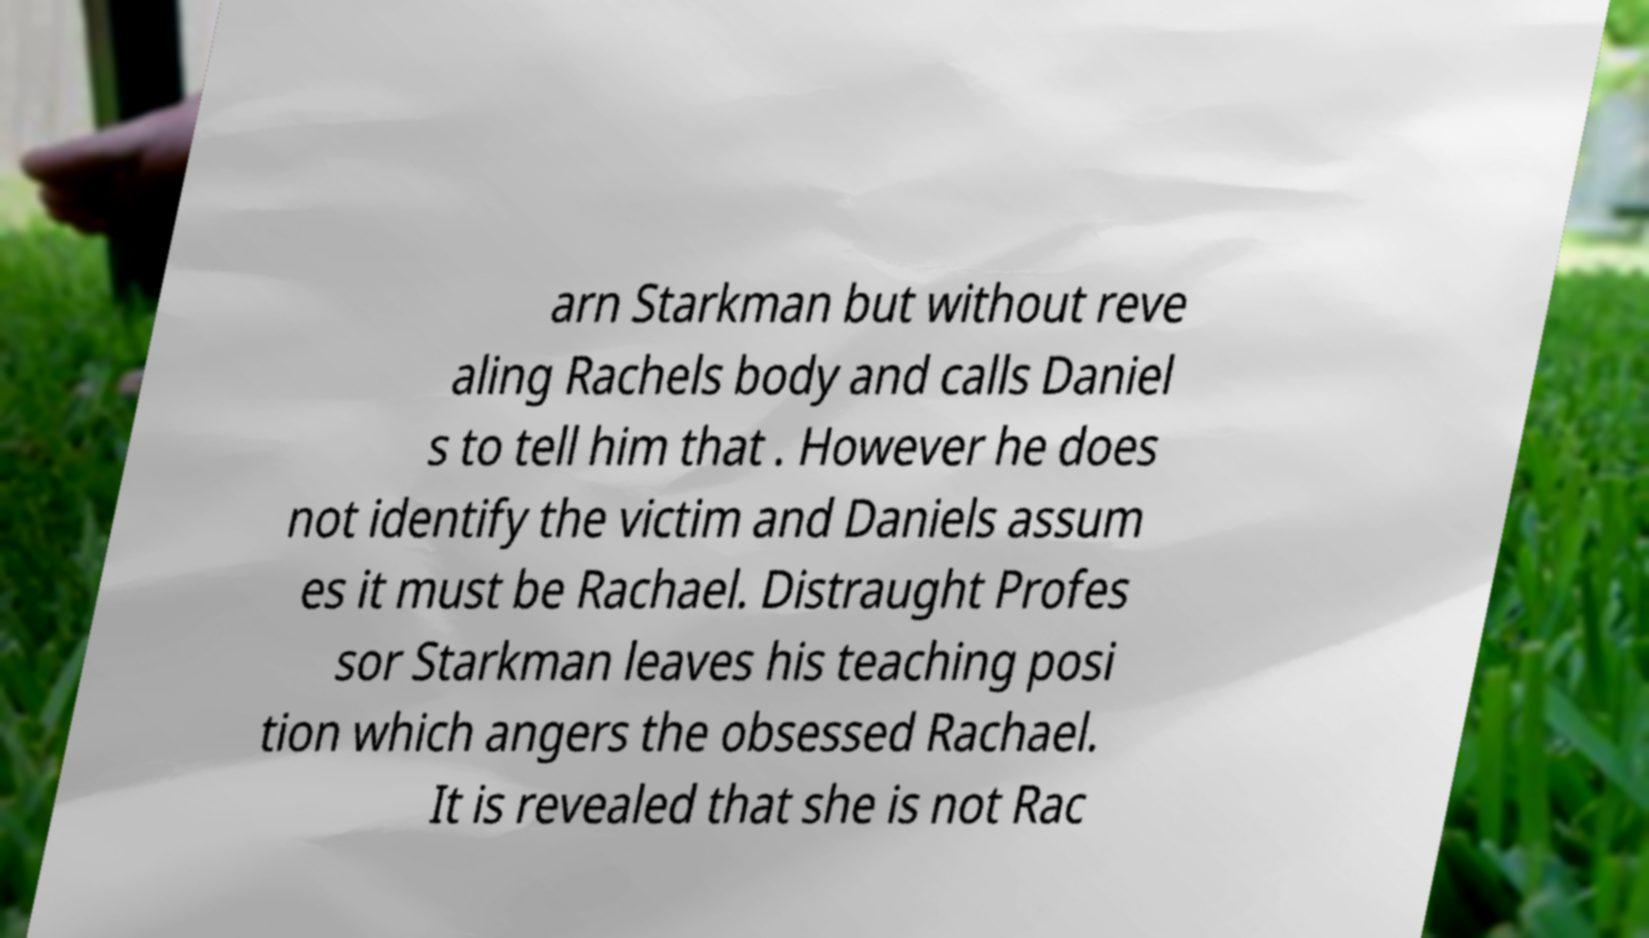Please identify and transcribe the text found in this image. arn Starkman but without reve aling Rachels body and calls Daniel s to tell him that . However he does not identify the victim and Daniels assum es it must be Rachael. Distraught Profes sor Starkman leaves his teaching posi tion which angers the obsessed Rachael. It is revealed that she is not Rac 